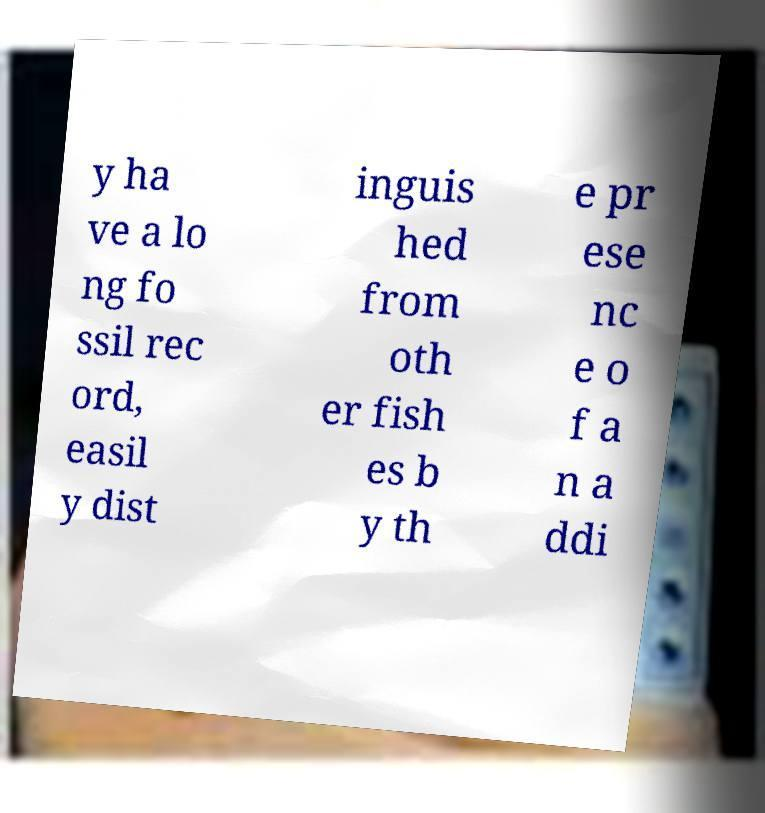Could you assist in decoding the text presented in this image and type it out clearly? y ha ve a lo ng fo ssil rec ord, easil y dist inguis hed from oth er fish es b y th e pr ese nc e o f a n a ddi 